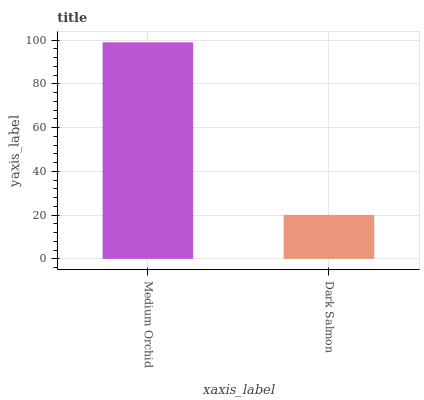Is Dark Salmon the minimum?
Answer yes or no. Yes. Is Medium Orchid the maximum?
Answer yes or no. Yes. Is Dark Salmon the maximum?
Answer yes or no. No. Is Medium Orchid greater than Dark Salmon?
Answer yes or no. Yes. Is Dark Salmon less than Medium Orchid?
Answer yes or no. Yes. Is Dark Salmon greater than Medium Orchid?
Answer yes or no. No. Is Medium Orchid less than Dark Salmon?
Answer yes or no. No. Is Medium Orchid the high median?
Answer yes or no. Yes. Is Dark Salmon the low median?
Answer yes or no. Yes. Is Dark Salmon the high median?
Answer yes or no. No. Is Medium Orchid the low median?
Answer yes or no. No. 